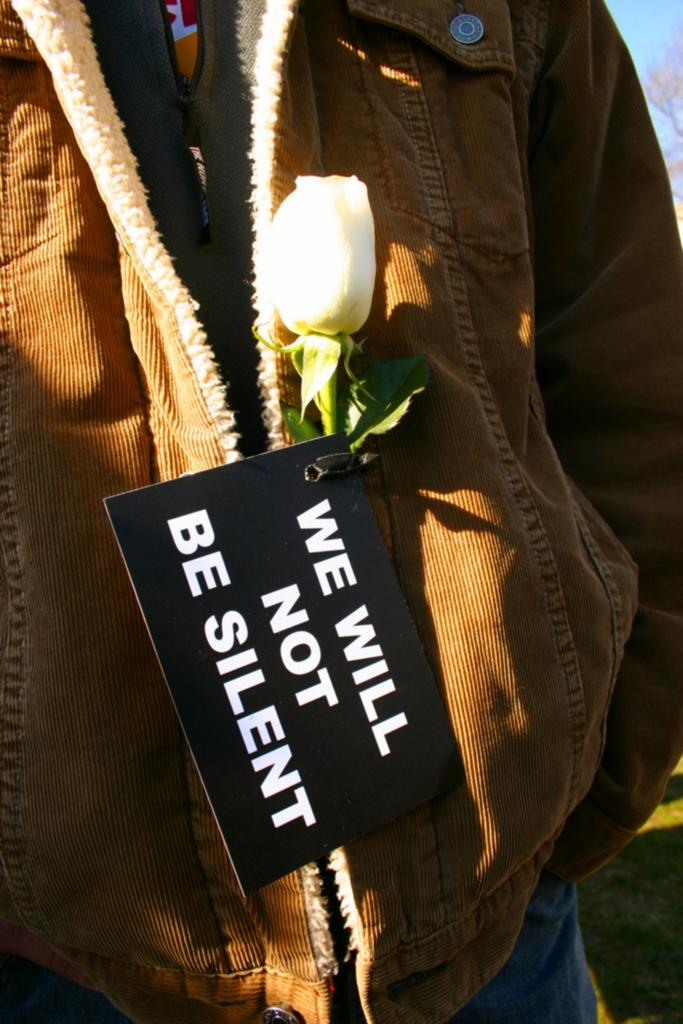Who or what is the main subject in the image? There is a person in the image. What other object can be seen in the image besides the person? There is a flower in the image. Can you describe any additional details about the person in the image? There is a board on the person's jacket. What type of grass can be seen growing on the person's elbow in the image? There is no grass visible in the image, nor is there any indication of an elbow. 